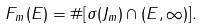<formula> <loc_0><loc_0><loc_500><loc_500>F _ { m } ( E ) = \# [ \sigma ( J _ { m } ) \cap ( E , \infty ) ] .</formula> 